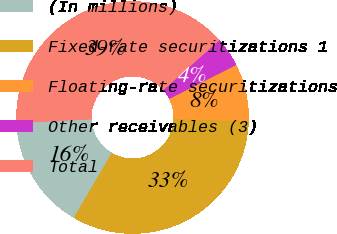Convert chart to OTSL. <chart><loc_0><loc_0><loc_500><loc_500><pie_chart><fcel>(In millions)<fcel>Fixed-rate securitizations 1<fcel>Floating-rate securitizations<fcel>Other receivables (3)<fcel>Total<nl><fcel>15.82%<fcel>32.89%<fcel>8.01%<fcel>4.11%<fcel>39.17%<nl></chart> 